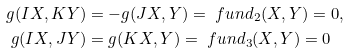Convert formula to latex. <formula><loc_0><loc_0><loc_500><loc_500>g ( I X , K Y ) & = - g ( J X , Y ) = \ f u n d _ { 2 } ( X , Y ) = 0 , \\ g ( I X , J Y ) & = g ( K X , Y ) = \ f u n d _ { 3 } ( X , Y ) = 0</formula> 